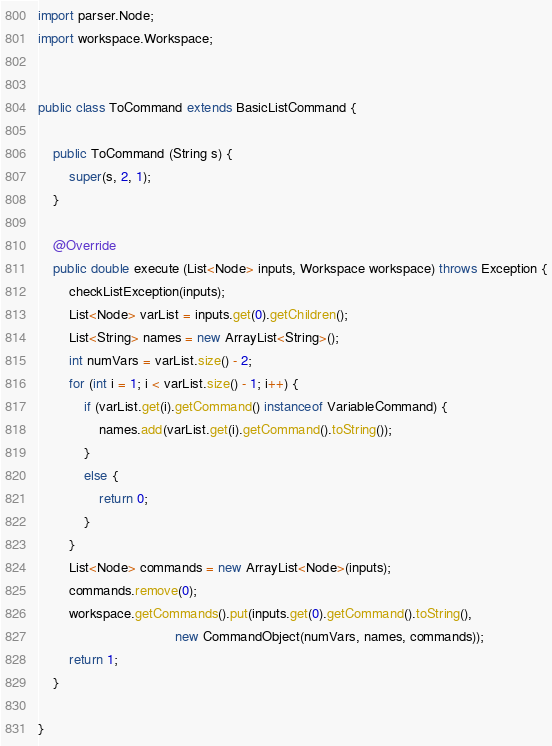<code> <loc_0><loc_0><loc_500><loc_500><_Java_>import parser.Node;
import workspace.Workspace;


public class ToCommand extends BasicListCommand {

    public ToCommand (String s) {
        super(s, 2, 1);
    }

    @Override
    public double execute (List<Node> inputs, Workspace workspace) throws Exception {
        checkListException(inputs);
        List<Node> varList = inputs.get(0).getChildren();
        List<String> names = new ArrayList<String>();
        int numVars = varList.size() - 2;
        for (int i = 1; i < varList.size() - 1; i++) {
            if (varList.get(i).getCommand() instanceof VariableCommand) {
                names.add(varList.get(i).getCommand().toString());
            }
            else {
                return 0;
            }
        }
        List<Node> commands = new ArrayList<Node>(inputs);
        commands.remove(0);
        workspace.getCommands().put(inputs.get(0).getCommand().toString(),
                                    new CommandObject(numVars, names, commands));
        return 1;
    }

}
</code> 